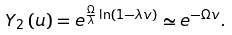<formula> <loc_0><loc_0><loc_500><loc_500>Y _ { 2 } \left ( u \right ) = e ^ { \frac { \Omega } { \lambda } \ln \left ( 1 - \lambda v \right ) } \simeq e ^ { - \Omega v } .</formula> 